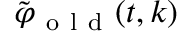<formula> <loc_0><loc_0><loc_500><loc_500>\tilde { \varphi } _ { o l d } ( t , k )</formula> 